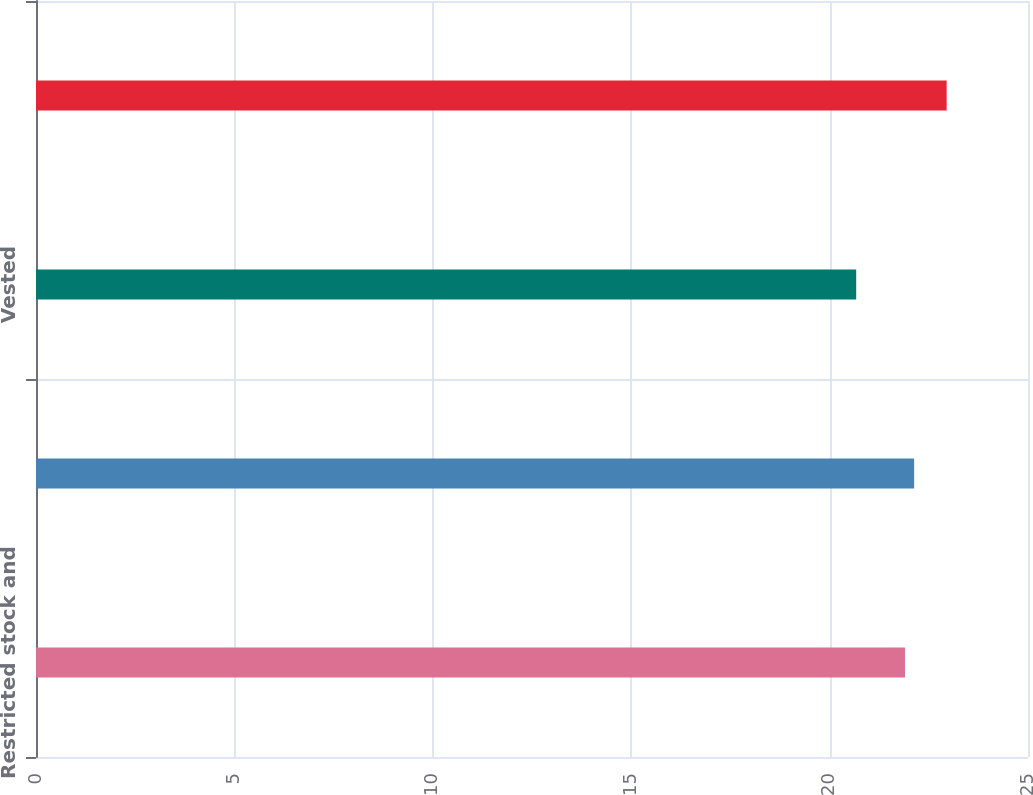<chart> <loc_0><loc_0><loc_500><loc_500><bar_chart><fcel>Restricted stock and<fcel>Granted<fcel>Vested<fcel>Forfeited<nl><fcel>21.9<fcel>22.13<fcel>20.67<fcel>22.95<nl></chart> 